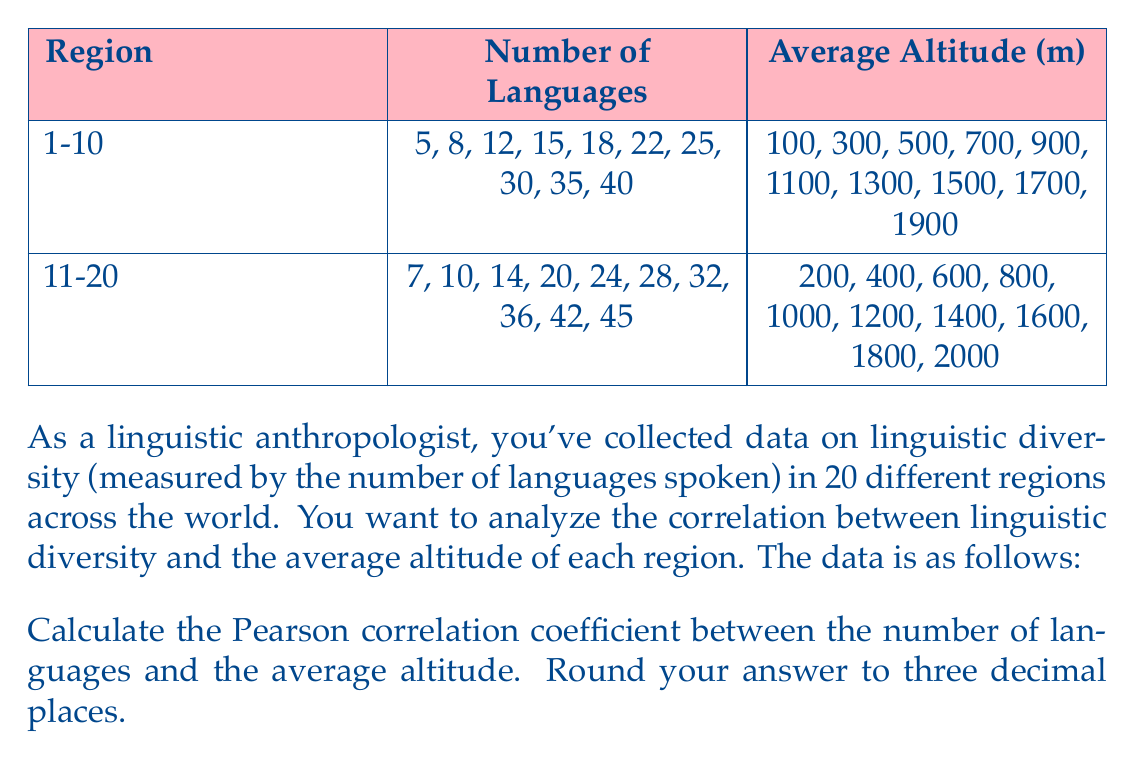Help me with this question. To calculate the Pearson correlation coefficient, we'll follow these steps:

1. Calculate the means of X (number of languages) and Y (average altitude):
   $$\bar{X} = \frac{\sum_{i=1}^{20} X_i}{20} = 23.4$$
   $$\bar{Y} = \frac{\sum_{i=1}^{20} Y_i}{20} = 1000$$

2. Calculate the deviations from the means:
   $$(X_i - \bar{X})$$ and $$(Y_i - \bar{Y})$$

3. Calculate the products of the deviations:
   $$(X_i - \bar{X})(Y_i - \bar{Y})$$

4. Sum the products of the deviations:
   $$\sum_{i=1}^{20} (X_i - \bar{X})(Y_i - \bar{Y}) = 684,600$$

5. Calculate the sum of squared deviations for X and Y:
   $$\sum_{i=1}^{20} (X_i - \bar{X})^2 = 3,215.2$$
   $$\sum_{i=1}^{20} (Y_i - \bar{Y})^2 = 3,800,000$$

6. Apply the Pearson correlation coefficient formula:
   $$r = \frac{\sum_{i=1}^{20} (X_i - \bar{X})(Y_i - \bar{Y})}{\sqrt{\sum_{i=1}^{20} (X_i - \bar{X})^2 \sum_{i=1}^{20} (Y_i - \bar{Y})^2}}$$

   $$r = \frac{684,600}{\sqrt{3,215.2 \times 3,800,000}} \approx 0.9739$$

7. Round to three decimal places: 0.974
Answer: 0.974 